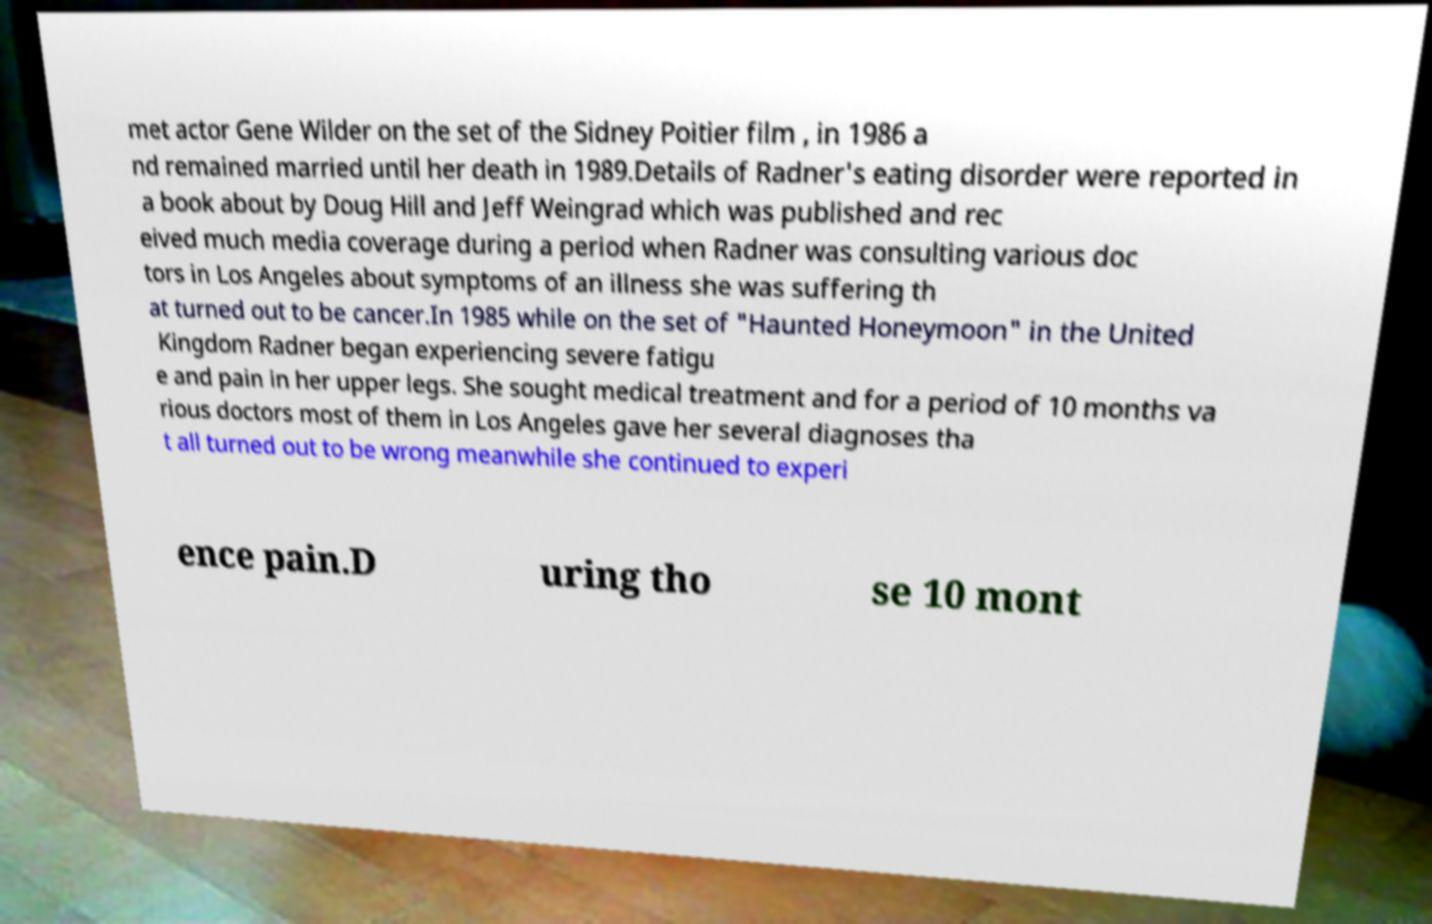Could you extract and type out the text from this image? met actor Gene Wilder on the set of the Sidney Poitier film , in 1986 a nd remained married until her death in 1989.Details of Radner's eating disorder were reported in a book about by Doug Hill and Jeff Weingrad which was published and rec eived much media coverage during a period when Radner was consulting various doc tors in Los Angeles about symptoms of an illness she was suffering th at turned out to be cancer.In 1985 while on the set of "Haunted Honeymoon" in the United Kingdom Radner began experiencing severe fatigu e and pain in her upper legs. She sought medical treatment and for a period of 10 months va rious doctors most of them in Los Angeles gave her several diagnoses tha t all turned out to be wrong meanwhile she continued to experi ence pain.D uring tho se 10 mont 